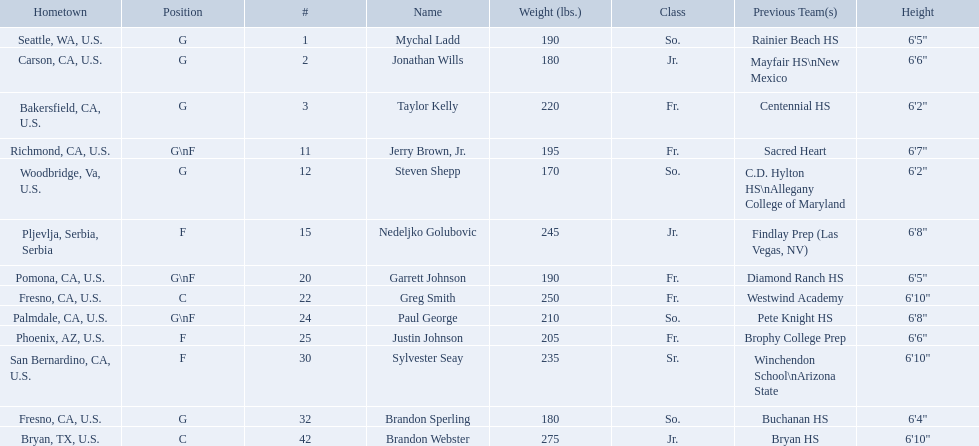What are the listed classes of the players? So., Jr., Fr., Fr., So., Jr., Fr., Fr., So., Fr., Sr., So., Jr. Which of these is not from the us? Jr. To which name does that entry correspond to? Nedeljko Golubovic. Who are all the players in the 2009-10 fresno state bulldogs men's basketball team? Mychal Ladd, Jonathan Wills, Taylor Kelly, Jerry Brown, Jr., Steven Shepp, Nedeljko Golubovic, Garrett Johnson, Greg Smith, Paul George, Justin Johnson, Sylvester Seay, Brandon Sperling, Brandon Webster. Of these players, who are the ones who play forward? Jerry Brown, Jr., Nedeljko Golubovic, Garrett Johnson, Paul George, Justin Johnson, Sylvester Seay. Of these players, which ones only play forward and no other position? Nedeljko Golubovic, Justin Johnson, Sylvester Seay. Of these players, who is the shortest? Justin Johnson. Which players are forwards? Nedeljko Golubovic, Paul George, Justin Johnson, Sylvester Seay. What are the heights of these players? Nedeljko Golubovic, 6'8", Paul George, 6'8", Justin Johnson, 6'6", Sylvester Seay, 6'10". Of these players, who is the shortest? Justin Johnson. Who are all the players? Mychal Ladd, Jonathan Wills, Taylor Kelly, Jerry Brown, Jr., Steven Shepp, Nedeljko Golubovic, Garrett Johnson, Greg Smith, Paul George, Justin Johnson, Sylvester Seay, Brandon Sperling, Brandon Webster. How tall are they? 6'5", 6'6", 6'2", 6'7", 6'2", 6'8", 6'5", 6'10", 6'8", 6'6", 6'10", 6'4", 6'10". What about just paul george and greg smitih? 6'10", 6'8". And which of the two is taller? Greg Smith. 